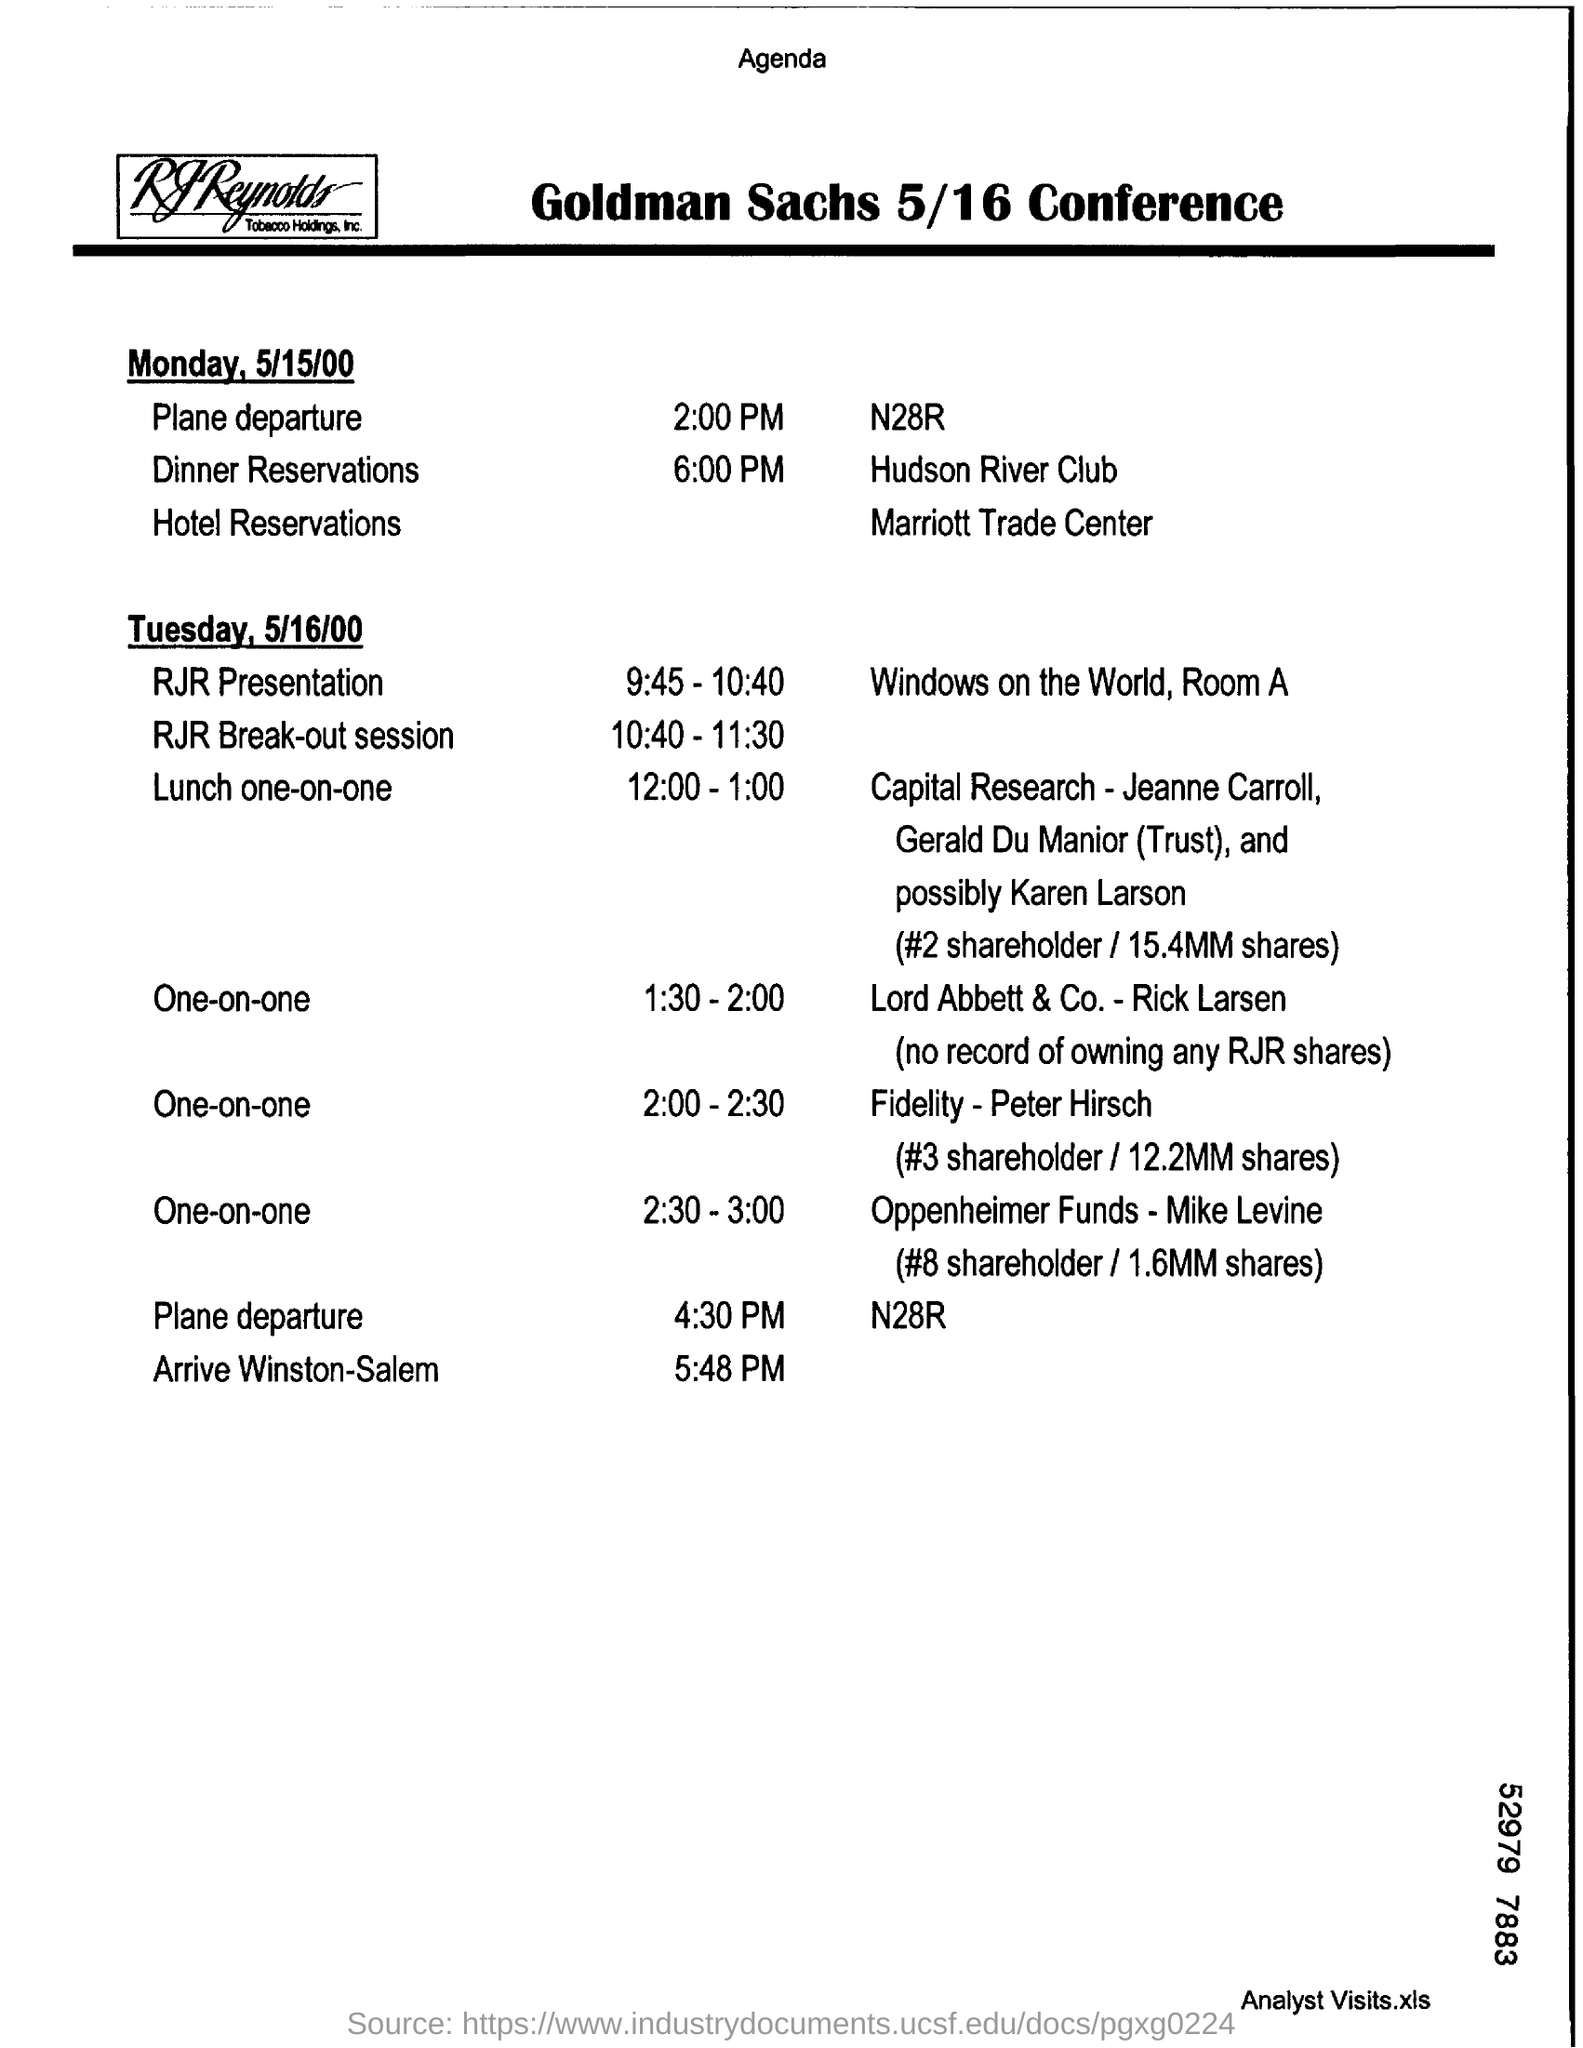At what time , does the plane departs on Monday, 5/15/00?
Give a very brief answer. 2:00 PM. Where is the Hotel Reservations made?
Provide a short and direct response. Marriott Trade Center. At what date, the RJR presentation takes place?
Provide a succinct answer. 5/16/00. What session is carried out during the time interval 10:40 - 11.30?
Make the answer very short. RJR Break-out session. At what time, does the plane arrives Winston-Salem?
Your answer should be compact. 5:48 PM. Which conference Agenda is mentioned here?
Provide a succinct answer. Goldman Sachs 5/16 Conference. 